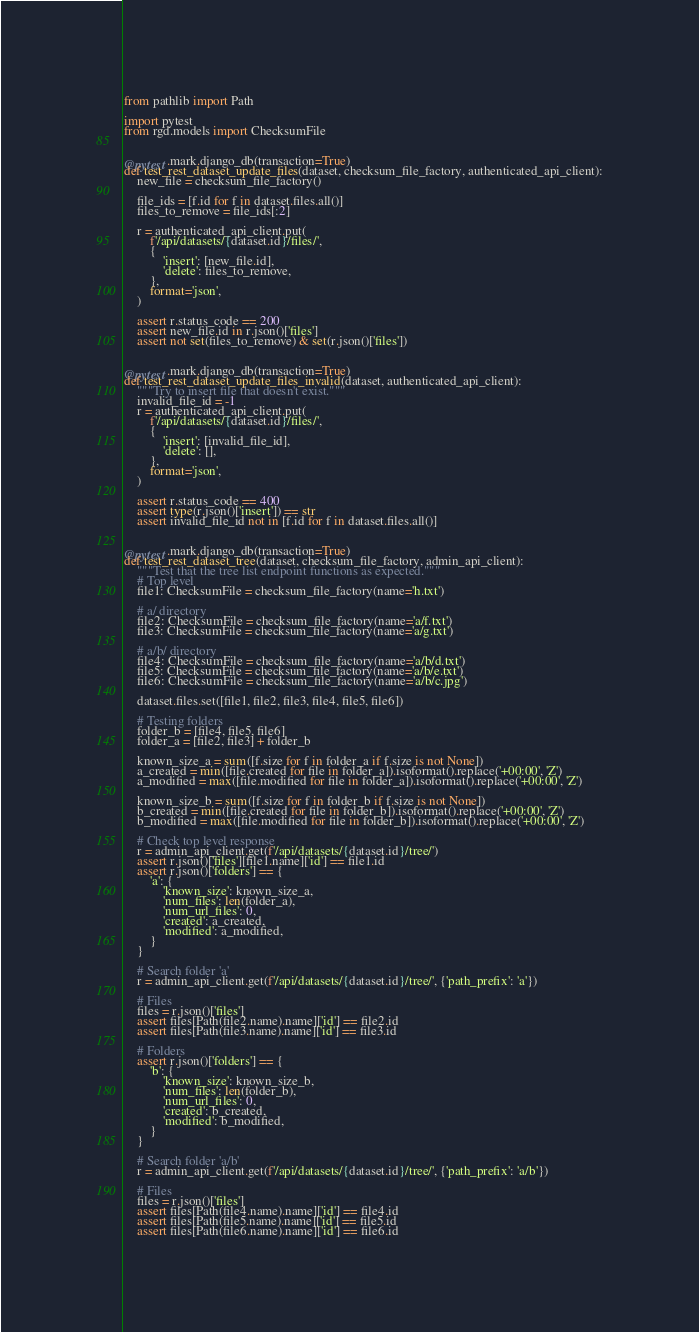Convert code to text. <code><loc_0><loc_0><loc_500><loc_500><_Python_>from pathlib import Path

import pytest
from rgd.models import ChecksumFile


@pytest.mark.django_db(transaction=True)
def test_rest_dataset_update_files(dataset, checksum_file_factory, authenticated_api_client):
    new_file = checksum_file_factory()

    file_ids = [f.id for f in dataset.files.all()]
    files_to_remove = file_ids[:2]

    r = authenticated_api_client.put(
        f'/api/datasets/{dataset.id}/files/',
        {
            'insert': [new_file.id],
            'delete': files_to_remove,
        },
        format='json',
    )

    assert r.status_code == 200
    assert new_file.id in r.json()['files']
    assert not set(files_to_remove) & set(r.json()['files'])


@pytest.mark.django_db(transaction=True)
def test_rest_dataset_update_files_invalid(dataset, authenticated_api_client):
    """Try to insert file that doesn't exist."""
    invalid_file_id = -1
    r = authenticated_api_client.put(
        f'/api/datasets/{dataset.id}/files/',
        {
            'insert': [invalid_file_id],
            'delete': [],
        },
        format='json',
    )

    assert r.status_code == 400
    assert type(r.json()['insert']) == str
    assert invalid_file_id not in [f.id for f in dataset.files.all()]


@pytest.mark.django_db(transaction=True)
def test_rest_dataset_tree(dataset, checksum_file_factory, admin_api_client):
    """Test that the tree list endpoint functions as expected."""
    # Top level
    file1: ChecksumFile = checksum_file_factory(name='h.txt')

    # a/ directory
    file2: ChecksumFile = checksum_file_factory(name='a/f.txt')
    file3: ChecksumFile = checksum_file_factory(name='a/g.txt')

    # a/b/ directory
    file4: ChecksumFile = checksum_file_factory(name='a/b/d.txt')
    file5: ChecksumFile = checksum_file_factory(name='a/b/e.txt')
    file6: ChecksumFile = checksum_file_factory(name='a/b/c.jpg')

    dataset.files.set([file1, file2, file3, file4, file5, file6])

    # Testing folders
    folder_b = [file4, file5, file6]
    folder_a = [file2, file3] + folder_b

    known_size_a = sum([f.size for f in folder_a if f.size is not None])
    a_created = min([file.created for file in folder_a]).isoformat().replace('+00:00', 'Z')
    a_modified = max([file.modified for file in folder_a]).isoformat().replace('+00:00', 'Z')

    known_size_b = sum([f.size for f in folder_b if f.size is not None])
    b_created = min([file.created for file in folder_b]).isoformat().replace('+00:00', 'Z')
    b_modified = max([file.modified for file in folder_b]).isoformat().replace('+00:00', 'Z')

    # Check top level response
    r = admin_api_client.get(f'/api/datasets/{dataset.id}/tree/')
    assert r.json()['files'][file1.name]['id'] == file1.id
    assert r.json()['folders'] == {
        'a': {
            'known_size': known_size_a,
            'num_files': len(folder_a),
            'num_url_files': 0,
            'created': a_created,
            'modified': a_modified,
        }
    }

    # Search folder 'a'
    r = admin_api_client.get(f'/api/datasets/{dataset.id}/tree/', {'path_prefix': 'a'})

    # Files
    files = r.json()['files']
    assert files[Path(file2.name).name]['id'] == file2.id
    assert files[Path(file3.name).name]['id'] == file3.id

    # Folders
    assert r.json()['folders'] == {
        'b': {
            'known_size': known_size_b,
            'num_files': len(folder_b),
            'num_url_files': 0,
            'created': b_created,
            'modified': b_modified,
        }
    }

    # Search folder 'a/b'
    r = admin_api_client.get(f'/api/datasets/{dataset.id}/tree/', {'path_prefix': 'a/b'})

    # Files
    files = r.json()['files']
    assert files[Path(file4.name).name]['id'] == file4.id
    assert files[Path(file5.name).name]['id'] == file5.id
    assert files[Path(file6.name).name]['id'] == file6.id
</code> 